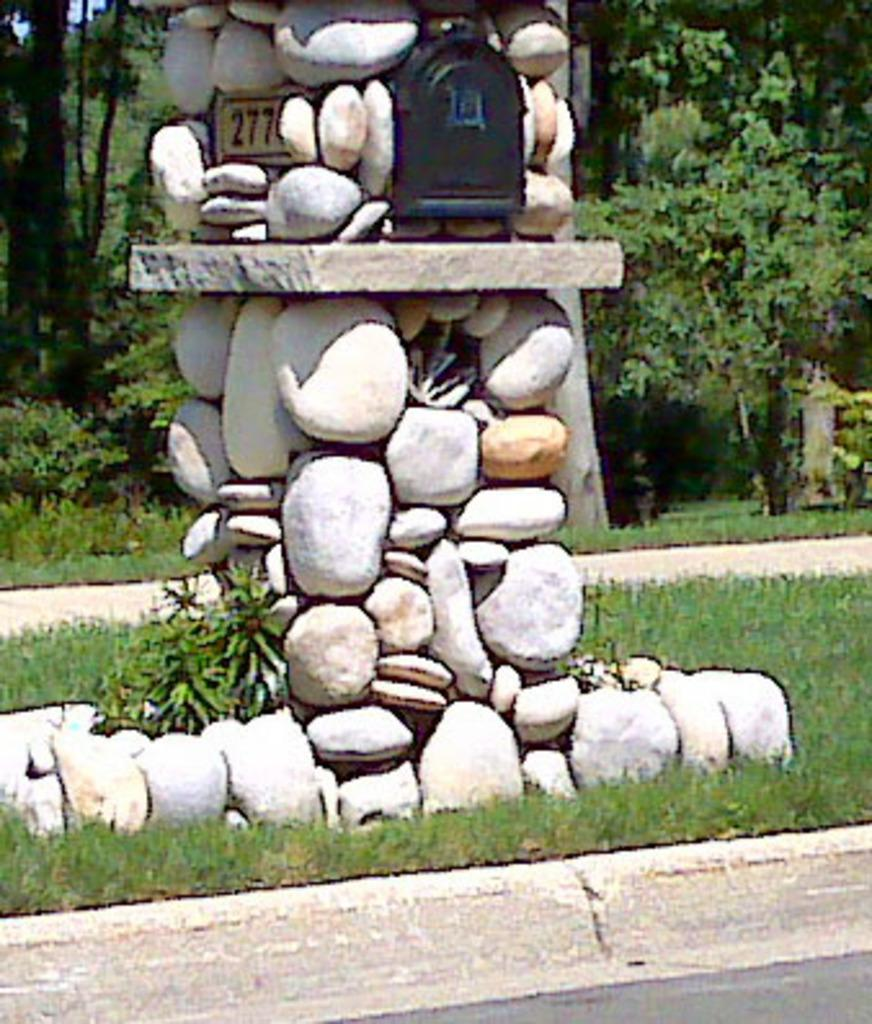What is the arrangement of the rocks in the image? The rocks are arranged in the image. What can be found between the rocks? There are objects between the rocks. What type of vegetation is visible in the background of the image? There are trees and grass in the background of the image. What type of crime is being committed in the image? There is no crime being committed in the image; it features rocks arranged with objects between them and trees and grass in the background. 